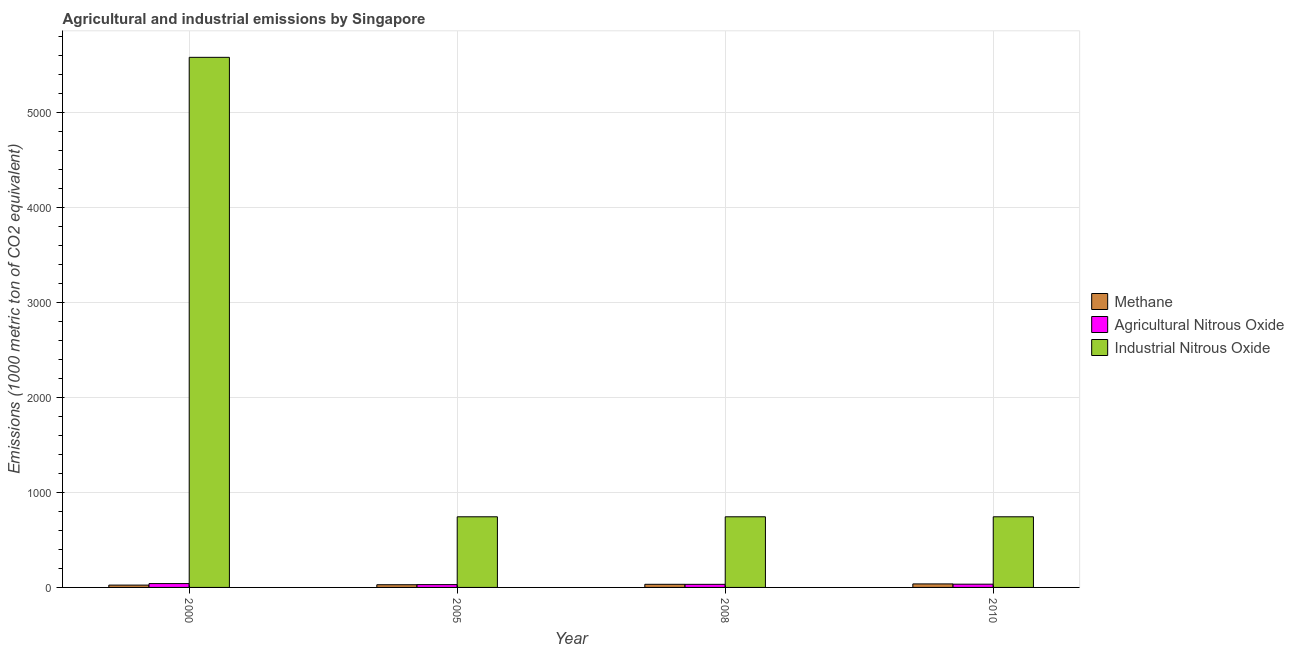How many different coloured bars are there?
Provide a short and direct response. 3. How many bars are there on the 1st tick from the right?
Offer a terse response. 3. What is the amount of industrial nitrous oxide emissions in 2005?
Your answer should be very brief. 743.5. Across all years, what is the maximum amount of industrial nitrous oxide emissions?
Your response must be concise. 5580. Across all years, what is the minimum amount of methane emissions?
Provide a succinct answer. 24.4. In which year was the amount of methane emissions maximum?
Your response must be concise. 2010. What is the total amount of methane emissions in the graph?
Give a very brief answer. 122.5. What is the difference between the amount of methane emissions in 2010 and the amount of agricultural nitrous oxide emissions in 2000?
Keep it short and to the point. 12.5. What is the average amount of methane emissions per year?
Offer a very short reply. 30.62. In the year 2000, what is the difference between the amount of agricultural nitrous oxide emissions and amount of industrial nitrous oxide emissions?
Provide a short and direct response. 0. In how many years, is the amount of industrial nitrous oxide emissions greater than 2800 metric ton?
Your answer should be very brief. 1. What is the ratio of the amount of agricultural nitrous oxide emissions in 2000 to that in 2005?
Offer a very short reply. 1.37. What is the difference between the highest and the second highest amount of agricultural nitrous oxide emissions?
Offer a very short reply. 6.4. What is the difference between the highest and the lowest amount of industrial nitrous oxide emissions?
Keep it short and to the point. 4836.5. In how many years, is the amount of methane emissions greater than the average amount of methane emissions taken over all years?
Make the answer very short. 2. What does the 3rd bar from the left in 2010 represents?
Your response must be concise. Industrial Nitrous Oxide. What does the 3rd bar from the right in 2010 represents?
Provide a succinct answer. Methane. What is the difference between two consecutive major ticks on the Y-axis?
Keep it short and to the point. 1000. Does the graph contain grids?
Your answer should be very brief. Yes. Where does the legend appear in the graph?
Your answer should be very brief. Center right. What is the title of the graph?
Keep it short and to the point. Agricultural and industrial emissions by Singapore. What is the label or title of the X-axis?
Offer a very short reply. Year. What is the label or title of the Y-axis?
Ensure brevity in your answer.  Emissions (1000 metric ton of CO2 equivalent). What is the Emissions (1000 metric ton of CO2 equivalent) of Methane in 2000?
Keep it short and to the point. 24.4. What is the Emissions (1000 metric ton of CO2 equivalent) of Agricultural Nitrous Oxide in 2000?
Provide a short and direct response. 40.5. What is the Emissions (1000 metric ton of CO2 equivalent) in Industrial Nitrous Oxide in 2000?
Give a very brief answer. 5580. What is the Emissions (1000 metric ton of CO2 equivalent) in Methane in 2005?
Your answer should be compact. 28.4. What is the Emissions (1000 metric ton of CO2 equivalent) of Agricultural Nitrous Oxide in 2005?
Your response must be concise. 29.5. What is the Emissions (1000 metric ton of CO2 equivalent) of Industrial Nitrous Oxide in 2005?
Your answer should be compact. 743.5. What is the Emissions (1000 metric ton of CO2 equivalent) in Methane in 2008?
Your response must be concise. 32.8. What is the Emissions (1000 metric ton of CO2 equivalent) in Agricultural Nitrous Oxide in 2008?
Ensure brevity in your answer.  32.6. What is the Emissions (1000 metric ton of CO2 equivalent) of Industrial Nitrous Oxide in 2008?
Offer a terse response. 743.5. What is the Emissions (1000 metric ton of CO2 equivalent) in Methane in 2010?
Offer a very short reply. 36.9. What is the Emissions (1000 metric ton of CO2 equivalent) of Agricultural Nitrous Oxide in 2010?
Keep it short and to the point. 34.1. What is the Emissions (1000 metric ton of CO2 equivalent) of Industrial Nitrous Oxide in 2010?
Your response must be concise. 743.5. Across all years, what is the maximum Emissions (1000 metric ton of CO2 equivalent) in Methane?
Your response must be concise. 36.9. Across all years, what is the maximum Emissions (1000 metric ton of CO2 equivalent) in Agricultural Nitrous Oxide?
Provide a succinct answer. 40.5. Across all years, what is the maximum Emissions (1000 metric ton of CO2 equivalent) in Industrial Nitrous Oxide?
Your answer should be compact. 5580. Across all years, what is the minimum Emissions (1000 metric ton of CO2 equivalent) in Methane?
Your response must be concise. 24.4. Across all years, what is the minimum Emissions (1000 metric ton of CO2 equivalent) of Agricultural Nitrous Oxide?
Keep it short and to the point. 29.5. Across all years, what is the minimum Emissions (1000 metric ton of CO2 equivalent) in Industrial Nitrous Oxide?
Ensure brevity in your answer.  743.5. What is the total Emissions (1000 metric ton of CO2 equivalent) in Methane in the graph?
Your answer should be compact. 122.5. What is the total Emissions (1000 metric ton of CO2 equivalent) of Agricultural Nitrous Oxide in the graph?
Your answer should be very brief. 136.7. What is the total Emissions (1000 metric ton of CO2 equivalent) of Industrial Nitrous Oxide in the graph?
Keep it short and to the point. 7810.5. What is the difference between the Emissions (1000 metric ton of CO2 equivalent) in Methane in 2000 and that in 2005?
Ensure brevity in your answer.  -4. What is the difference between the Emissions (1000 metric ton of CO2 equivalent) of Industrial Nitrous Oxide in 2000 and that in 2005?
Offer a very short reply. 4836.5. What is the difference between the Emissions (1000 metric ton of CO2 equivalent) in Agricultural Nitrous Oxide in 2000 and that in 2008?
Ensure brevity in your answer.  7.9. What is the difference between the Emissions (1000 metric ton of CO2 equivalent) of Industrial Nitrous Oxide in 2000 and that in 2008?
Your response must be concise. 4836.5. What is the difference between the Emissions (1000 metric ton of CO2 equivalent) of Agricultural Nitrous Oxide in 2000 and that in 2010?
Your answer should be very brief. 6.4. What is the difference between the Emissions (1000 metric ton of CO2 equivalent) of Industrial Nitrous Oxide in 2000 and that in 2010?
Provide a succinct answer. 4836.5. What is the difference between the Emissions (1000 metric ton of CO2 equivalent) in Methane in 2005 and that in 2008?
Make the answer very short. -4.4. What is the difference between the Emissions (1000 metric ton of CO2 equivalent) of Agricultural Nitrous Oxide in 2005 and that in 2008?
Your answer should be very brief. -3.1. What is the difference between the Emissions (1000 metric ton of CO2 equivalent) in Industrial Nitrous Oxide in 2005 and that in 2008?
Your answer should be very brief. 0. What is the difference between the Emissions (1000 metric ton of CO2 equivalent) in Methane in 2005 and that in 2010?
Your answer should be compact. -8.5. What is the difference between the Emissions (1000 metric ton of CO2 equivalent) of Agricultural Nitrous Oxide in 2005 and that in 2010?
Give a very brief answer. -4.6. What is the difference between the Emissions (1000 metric ton of CO2 equivalent) of Industrial Nitrous Oxide in 2005 and that in 2010?
Make the answer very short. 0. What is the difference between the Emissions (1000 metric ton of CO2 equivalent) in Methane in 2008 and that in 2010?
Your answer should be very brief. -4.1. What is the difference between the Emissions (1000 metric ton of CO2 equivalent) in Agricultural Nitrous Oxide in 2008 and that in 2010?
Offer a terse response. -1.5. What is the difference between the Emissions (1000 metric ton of CO2 equivalent) of Methane in 2000 and the Emissions (1000 metric ton of CO2 equivalent) of Industrial Nitrous Oxide in 2005?
Your answer should be compact. -719.1. What is the difference between the Emissions (1000 metric ton of CO2 equivalent) of Agricultural Nitrous Oxide in 2000 and the Emissions (1000 metric ton of CO2 equivalent) of Industrial Nitrous Oxide in 2005?
Offer a terse response. -703. What is the difference between the Emissions (1000 metric ton of CO2 equivalent) in Methane in 2000 and the Emissions (1000 metric ton of CO2 equivalent) in Agricultural Nitrous Oxide in 2008?
Provide a short and direct response. -8.2. What is the difference between the Emissions (1000 metric ton of CO2 equivalent) in Methane in 2000 and the Emissions (1000 metric ton of CO2 equivalent) in Industrial Nitrous Oxide in 2008?
Provide a succinct answer. -719.1. What is the difference between the Emissions (1000 metric ton of CO2 equivalent) of Agricultural Nitrous Oxide in 2000 and the Emissions (1000 metric ton of CO2 equivalent) of Industrial Nitrous Oxide in 2008?
Offer a terse response. -703. What is the difference between the Emissions (1000 metric ton of CO2 equivalent) of Methane in 2000 and the Emissions (1000 metric ton of CO2 equivalent) of Industrial Nitrous Oxide in 2010?
Your response must be concise. -719.1. What is the difference between the Emissions (1000 metric ton of CO2 equivalent) in Agricultural Nitrous Oxide in 2000 and the Emissions (1000 metric ton of CO2 equivalent) in Industrial Nitrous Oxide in 2010?
Provide a short and direct response. -703. What is the difference between the Emissions (1000 metric ton of CO2 equivalent) in Methane in 2005 and the Emissions (1000 metric ton of CO2 equivalent) in Agricultural Nitrous Oxide in 2008?
Make the answer very short. -4.2. What is the difference between the Emissions (1000 metric ton of CO2 equivalent) in Methane in 2005 and the Emissions (1000 metric ton of CO2 equivalent) in Industrial Nitrous Oxide in 2008?
Make the answer very short. -715.1. What is the difference between the Emissions (1000 metric ton of CO2 equivalent) of Agricultural Nitrous Oxide in 2005 and the Emissions (1000 metric ton of CO2 equivalent) of Industrial Nitrous Oxide in 2008?
Your answer should be compact. -714. What is the difference between the Emissions (1000 metric ton of CO2 equivalent) of Methane in 2005 and the Emissions (1000 metric ton of CO2 equivalent) of Industrial Nitrous Oxide in 2010?
Make the answer very short. -715.1. What is the difference between the Emissions (1000 metric ton of CO2 equivalent) in Agricultural Nitrous Oxide in 2005 and the Emissions (1000 metric ton of CO2 equivalent) in Industrial Nitrous Oxide in 2010?
Your response must be concise. -714. What is the difference between the Emissions (1000 metric ton of CO2 equivalent) in Methane in 2008 and the Emissions (1000 metric ton of CO2 equivalent) in Industrial Nitrous Oxide in 2010?
Provide a short and direct response. -710.7. What is the difference between the Emissions (1000 metric ton of CO2 equivalent) in Agricultural Nitrous Oxide in 2008 and the Emissions (1000 metric ton of CO2 equivalent) in Industrial Nitrous Oxide in 2010?
Provide a short and direct response. -710.9. What is the average Emissions (1000 metric ton of CO2 equivalent) of Methane per year?
Your answer should be very brief. 30.62. What is the average Emissions (1000 metric ton of CO2 equivalent) of Agricultural Nitrous Oxide per year?
Ensure brevity in your answer.  34.17. What is the average Emissions (1000 metric ton of CO2 equivalent) in Industrial Nitrous Oxide per year?
Your answer should be compact. 1952.62. In the year 2000, what is the difference between the Emissions (1000 metric ton of CO2 equivalent) in Methane and Emissions (1000 metric ton of CO2 equivalent) in Agricultural Nitrous Oxide?
Your response must be concise. -16.1. In the year 2000, what is the difference between the Emissions (1000 metric ton of CO2 equivalent) in Methane and Emissions (1000 metric ton of CO2 equivalent) in Industrial Nitrous Oxide?
Make the answer very short. -5555.6. In the year 2000, what is the difference between the Emissions (1000 metric ton of CO2 equivalent) of Agricultural Nitrous Oxide and Emissions (1000 metric ton of CO2 equivalent) of Industrial Nitrous Oxide?
Provide a succinct answer. -5539.5. In the year 2005, what is the difference between the Emissions (1000 metric ton of CO2 equivalent) in Methane and Emissions (1000 metric ton of CO2 equivalent) in Industrial Nitrous Oxide?
Offer a terse response. -715.1. In the year 2005, what is the difference between the Emissions (1000 metric ton of CO2 equivalent) of Agricultural Nitrous Oxide and Emissions (1000 metric ton of CO2 equivalent) of Industrial Nitrous Oxide?
Ensure brevity in your answer.  -714. In the year 2008, what is the difference between the Emissions (1000 metric ton of CO2 equivalent) in Methane and Emissions (1000 metric ton of CO2 equivalent) in Industrial Nitrous Oxide?
Offer a very short reply. -710.7. In the year 2008, what is the difference between the Emissions (1000 metric ton of CO2 equivalent) of Agricultural Nitrous Oxide and Emissions (1000 metric ton of CO2 equivalent) of Industrial Nitrous Oxide?
Make the answer very short. -710.9. In the year 2010, what is the difference between the Emissions (1000 metric ton of CO2 equivalent) of Methane and Emissions (1000 metric ton of CO2 equivalent) of Agricultural Nitrous Oxide?
Offer a very short reply. 2.8. In the year 2010, what is the difference between the Emissions (1000 metric ton of CO2 equivalent) in Methane and Emissions (1000 metric ton of CO2 equivalent) in Industrial Nitrous Oxide?
Offer a terse response. -706.6. In the year 2010, what is the difference between the Emissions (1000 metric ton of CO2 equivalent) in Agricultural Nitrous Oxide and Emissions (1000 metric ton of CO2 equivalent) in Industrial Nitrous Oxide?
Provide a succinct answer. -709.4. What is the ratio of the Emissions (1000 metric ton of CO2 equivalent) in Methane in 2000 to that in 2005?
Make the answer very short. 0.86. What is the ratio of the Emissions (1000 metric ton of CO2 equivalent) in Agricultural Nitrous Oxide in 2000 to that in 2005?
Your answer should be very brief. 1.37. What is the ratio of the Emissions (1000 metric ton of CO2 equivalent) of Industrial Nitrous Oxide in 2000 to that in 2005?
Provide a succinct answer. 7.5. What is the ratio of the Emissions (1000 metric ton of CO2 equivalent) in Methane in 2000 to that in 2008?
Offer a terse response. 0.74. What is the ratio of the Emissions (1000 metric ton of CO2 equivalent) of Agricultural Nitrous Oxide in 2000 to that in 2008?
Your response must be concise. 1.24. What is the ratio of the Emissions (1000 metric ton of CO2 equivalent) of Industrial Nitrous Oxide in 2000 to that in 2008?
Give a very brief answer. 7.5. What is the ratio of the Emissions (1000 metric ton of CO2 equivalent) in Methane in 2000 to that in 2010?
Your answer should be very brief. 0.66. What is the ratio of the Emissions (1000 metric ton of CO2 equivalent) in Agricultural Nitrous Oxide in 2000 to that in 2010?
Offer a terse response. 1.19. What is the ratio of the Emissions (1000 metric ton of CO2 equivalent) of Industrial Nitrous Oxide in 2000 to that in 2010?
Your response must be concise. 7.5. What is the ratio of the Emissions (1000 metric ton of CO2 equivalent) in Methane in 2005 to that in 2008?
Give a very brief answer. 0.87. What is the ratio of the Emissions (1000 metric ton of CO2 equivalent) in Agricultural Nitrous Oxide in 2005 to that in 2008?
Keep it short and to the point. 0.9. What is the ratio of the Emissions (1000 metric ton of CO2 equivalent) of Methane in 2005 to that in 2010?
Provide a short and direct response. 0.77. What is the ratio of the Emissions (1000 metric ton of CO2 equivalent) of Agricultural Nitrous Oxide in 2005 to that in 2010?
Your answer should be compact. 0.87. What is the ratio of the Emissions (1000 metric ton of CO2 equivalent) in Methane in 2008 to that in 2010?
Your answer should be compact. 0.89. What is the ratio of the Emissions (1000 metric ton of CO2 equivalent) of Agricultural Nitrous Oxide in 2008 to that in 2010?
Give a very brief answer. 0.96. What is the difference between the highest and the second highest Emissions (1000 metric ton of CO2 equivalent) of Industrial Nitrous Oxide?
Keep it short and to the point. 4836.5. What is the difference between the highest and the lowest Emissions (1000 metric ton of CO2 equivalent) of Methane?
Give a very brief answer. 12.5. What is the difference between the highest and the lowest Emissions (1000 metric ton of CO2 equivalent) of Agricultural Nitrous Oxide?
Offer a very short reply. 11. What is the difference between the highest and the lowest Emissions (1000 metric ton of CO2 equivalent) in Industrial Nitrous Oxide?
Ensure brevity in your answer.  4836.5. 